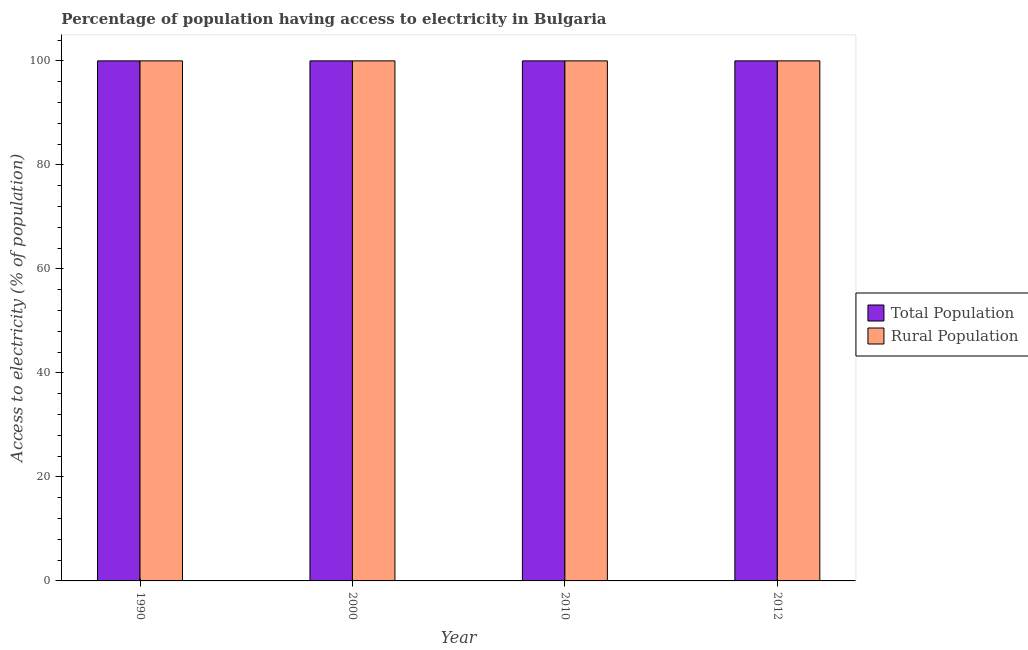How many different coloured bars are there?
Provide a short and direct response. 2. How many groups of bars are there?
Provide a short and direct response. 4. How many bars are there on the 2nd tick from the left?
Provide a succinct answer. 2. How many bars are there on the 4th tick from the right?
Give a very brief answer. 2. What is the label of the 3rd group of bars from the left?
Provide a short and direct response. 2010. In how many cases, is the number of bars for a given year not equal to the number of legend labels?
Make the answer very short. 0. What is the percentage of population having access to electricity in 2012?
Provide a short and direct response. 100. Across all years, what is the maximum percentage of rural population having access to electricity?
Make the answer very short. 100. Across all years, what is the minimum percentage of rural population having access to electricity?
Give a very brief answer. 100. In which year was the percentage of rural population having access to electricity minimum?
Give a very brief answer. 1990. What is the total percentage of rural population having access to electricity in the graph?
Your response must be concise. 400. What is the difference between the percentage of rural population having access to electricity in 1990 and the percentage of population having access to electricity in 2012?
Keep it short and to the point. 0. What is the average percentage of population having access to electricity per year?
Give a very brief answer. 100. Is the percentage of rural population having access to electricity in 2000 less than that in 2010?
Your response must be concise. No. Is the difference between the percentage of rural population having access to electricity in 1990 and 2010 greater than the difference between the percentage of population having access to electricity in 1990 and 2010?
Offer a very short reply. No. What is the difference between the highest and the second highest percentage of rural population having access to electricity?
Your response must be concise. 0. Is the sum of the percentage of population having access to electricity in 1990 and 2012 greater than the maximum percentage of rural population having access to electricity across all years?
Make the answer very short. Yes. What does the 2nd bar from the left in 2012 represents?
Give a very brief answer. Rural Population. What does the 1st bar from the right in 2012 represents?
Offer a terse response. Rural Population. How many bars are there?
Offer a very short reply. 8. Are all the bars in the graph horizontal?
Provide a short and direct response. No. Does the graph contain any zero values?
Provide a short and direct response. No. Does the graph contain grids?
Give a very brief answer. No. Where does the legend appear in the graph?
Your answer should be compact. Center right. How many legend labels are there?
Provide a succinct answer. 2. How are the legend labels stacked?
Keep it short and to the point. Vertical. What is the title of the graph?
Offer a very short reply. Percentage of population having access to electricity in Bulgaria. What is the label or title of the X-axis?
Your answer should be very brief. Year. What is the label or title of the Y-axis?
Ensure brevity in your answer.  Access to electricity (% of population). What is the Access to electricity (% of population) in Rural Population in 1990?
Give a very brief answer. 100. What is the Access to electricity (% of population) of Total Population in 2012?
Ensure brevity in your answer.  100. What is the Access to electricity (% of population) of Rural Population in 2012?
Your answer should be very brief. 100. Across all years, what is the minimum Access to electricity (% of population) of Rural Population?
Provide a succinct answer. 100. What is the total Access to electricity (% of population) of Total Population in the graph?
Provide a short and direct response. 400. What is the difference between the Access to electricity (% of population) in Total Population in 1990 and that in 2010?
Offer a terse response. 0. What is the difference between the Access to electricity (% of population) of Rural Population in 1990 and that in 2010?
Your answer should be compact. 0. What is the difference between the Access to electricity (% of population) of Total Population in 2000 and that in 2012?
Give a very brief answer. 0. What is the difference between the Access to electricity (% of population) of Total Population in 2010 and that in 2012?
Provide a succinct answer. 0. What is the difference between the Access to electricity (% of population) in Total Population in 2000 and the Access to electricity (% of population) in Rural Population in 2012?
Your answer should be compact. 0. What is the difference between the Access to electricity (% of population) in Total Population in 2010 and the Access to electricity (% of population) in Rural Population in 2012?
Offer a terse response. 0. What is the average Access to electricity (% of population) of Total Population per year?
Keep it short and to the point. 100. In the year 1990, what is the difference between the Access to electricity (% of population) in Total Population and Access to electricity (% of population) in Rural Population?
Make the answer very short. 0. What is the ratio of the Access to electricity (% of population) of Total Population in 1990 to that in 2000?
Your response must be concise. 1. What is the ratio of the Access to electricity (% of population) of Rural Population in 1990 to that in 2000?
Offer a very short reply. 1. What is the ratio of the Access to electricity (% of population) of Rural Population in 1990 to that in 2010?
Keep it short and to the point. 1. What is the ratio of the Access to electricity (% of population) of Total Population in 1990 to that in 2012?
Provide a short and direct response. 1. What is the ratio of the Access to electricity (% of population) of Rural Population in 1990 to that in 2012?
Offer a very short reply. 1. What is the ratio of the Access to electricity (% of population) in Rural Population in 2000 to that in 2010?
Make the answer very short. 1. What is the ratio of the Access to electricity (% of population) in Rural Population in 2000 to that in 2012?
Make the answer very short. 1. What is the ratio of the Access to electricity (% of population) of Total Population in 2010 to that in 2012?
Give a very brief answer. 1. What is the ratio of the Access to electricity (% of population) in Rural Population in 2010 to that in 2012?
Keep it short and to the point. 1. What is the difference between the highest and the second highest Access to electricity (% of population) in Rural Population?
Your answer should be very brief. 0. What is the difference between the highest and the lowest Access to electricity (% of population) in Rural Population?
Give a very brief answer. 0. 